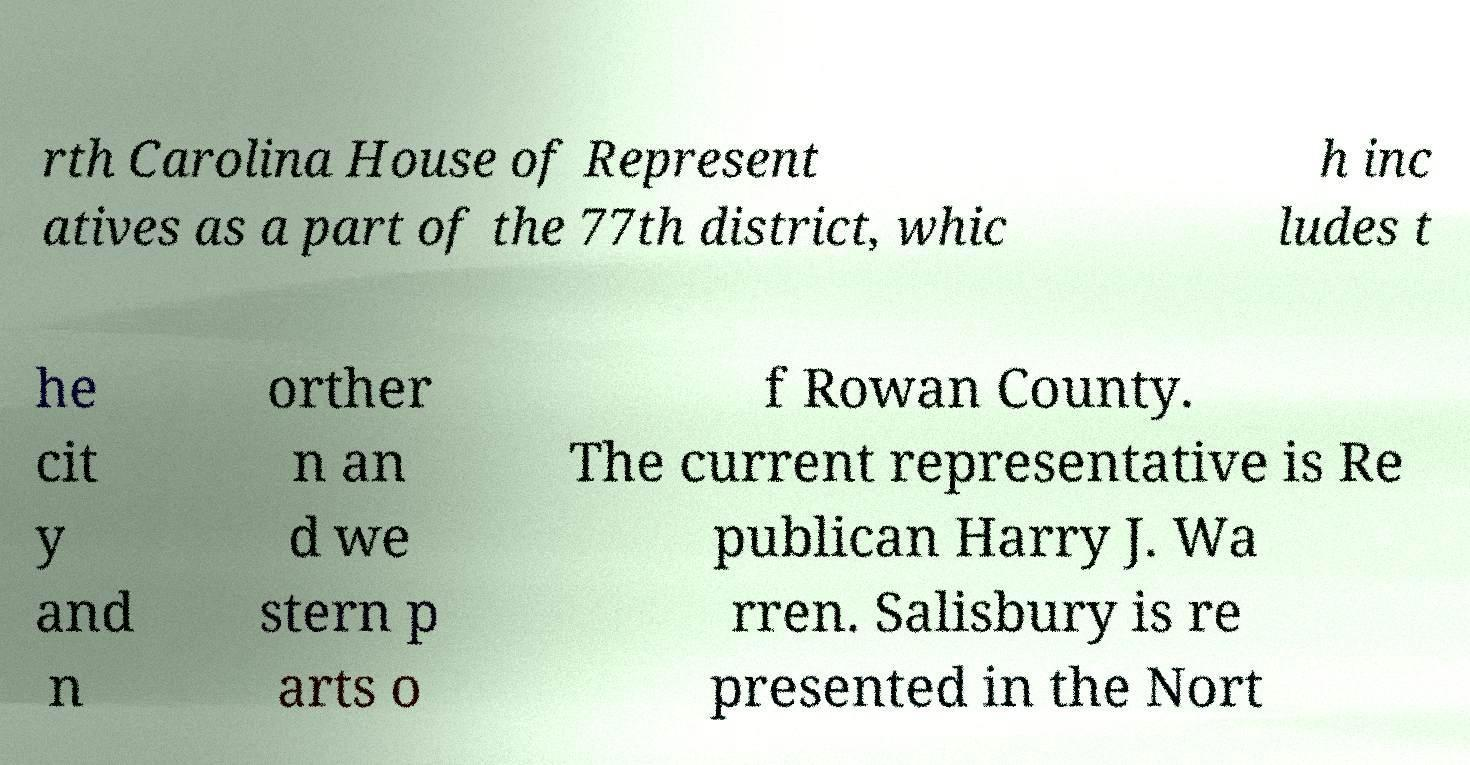Please read and relay the text visible in this image. What does it say? rth Carolina House of Represent atives as a part of the 77th district, whic h inc ludes t he cit y and n orther n an d we stern p arts o f Rowan County. The current representative is Re publican Harry J. Wa rren. Salisbury is re presented in the Nort 